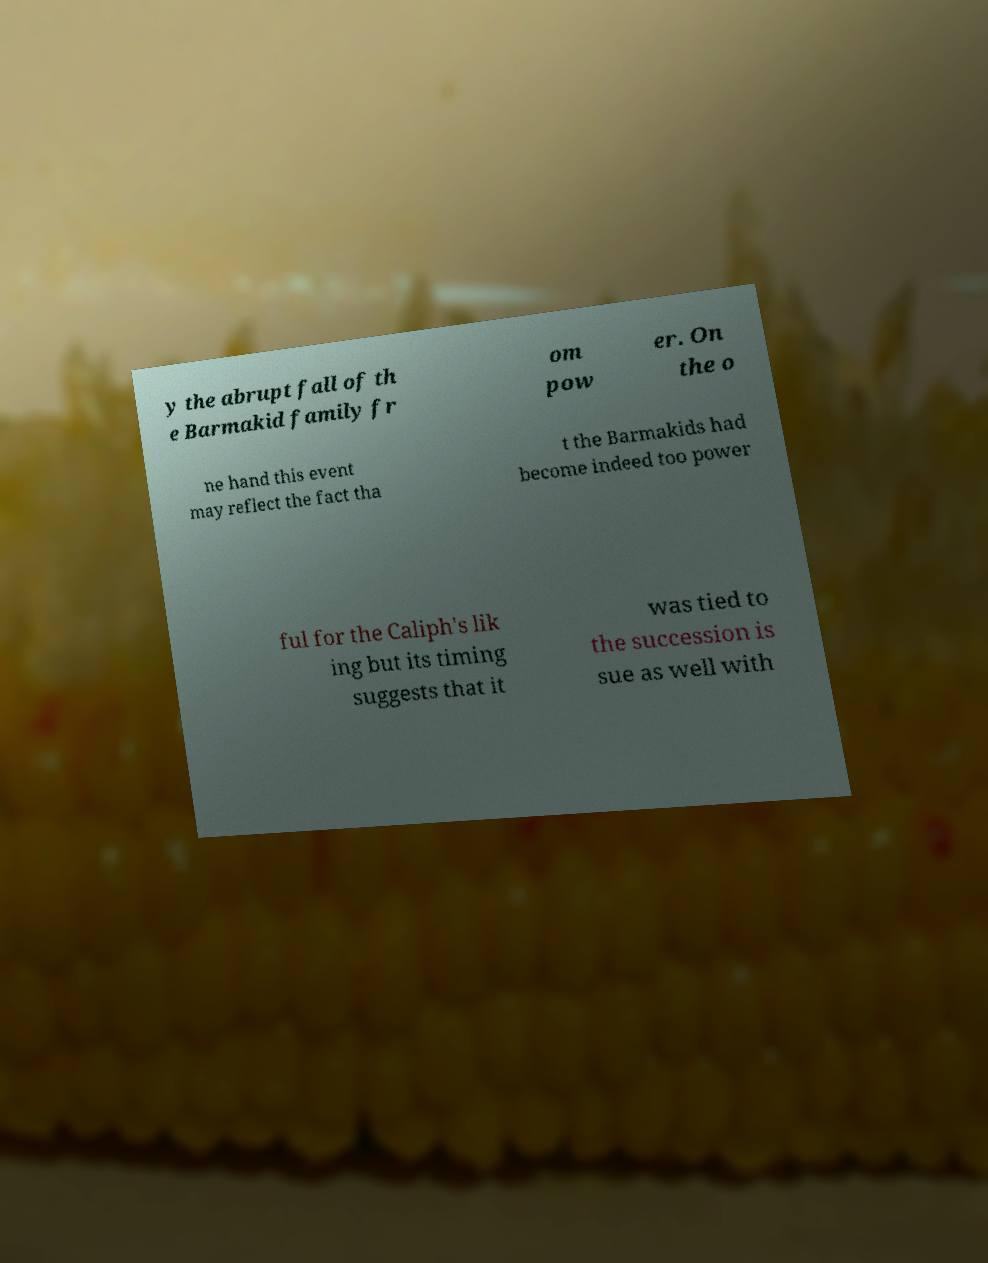Can you read and provide the text displayed in the image?This photo seems to have some interesting text. Can you extract and type it out for me? y the abrupt fall of th e Barmakid family fr om pow er. On the o ne hand this event may reflect the fact tha t the Barmakids had become indeed too power ful for the Caliph's lik ing but its timing suggests that it was tied to the succession is sue as well with 